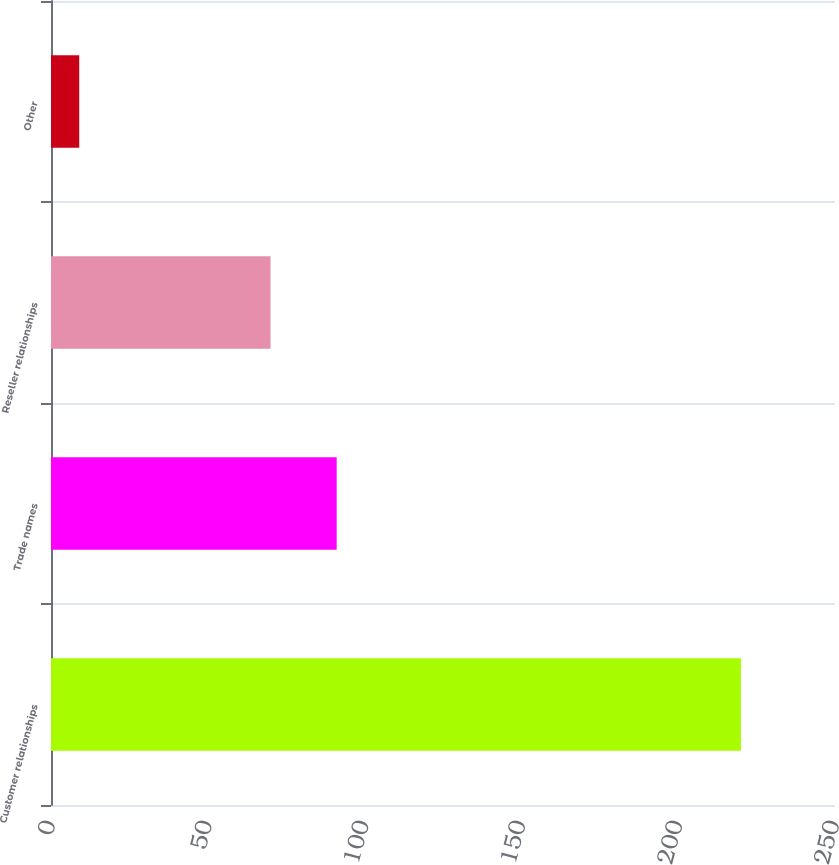Convert chart to OTSL. <chart><loc_0><loc_0><loc_500><loc_500><bar_chart><fcel>Customer relationships<fcel>Trade names<fcel>Reseller relationships<fcel>Other<nl><fcel>220<fcel>91.1<fcel>70<fcel>9<nl></chart> 